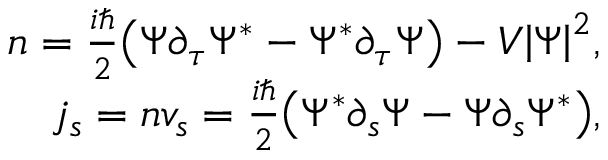<formula> <loc_0><loc_0><loc_500><loc_500>\begin{array} { r } { n = { \frac { i } { 2 } } { \left ( \Psi \partial _ { \tau } \Psi ^ { \ast } - \Psi ^ { \ast } \partial _ { \tau } \Psi \right ) } - V { \left | \Psi \right | } ^ { 2 } , } \\ { j _ { s } = n v _ { s } = { \frac { i } { 2 } } { \left ( \Psi ^ { \ast } \partial _ { s } \Psi - \Psi \partial _ { s } \Psi ^ { \ast } \right ) } , } \end{array}</formula> 